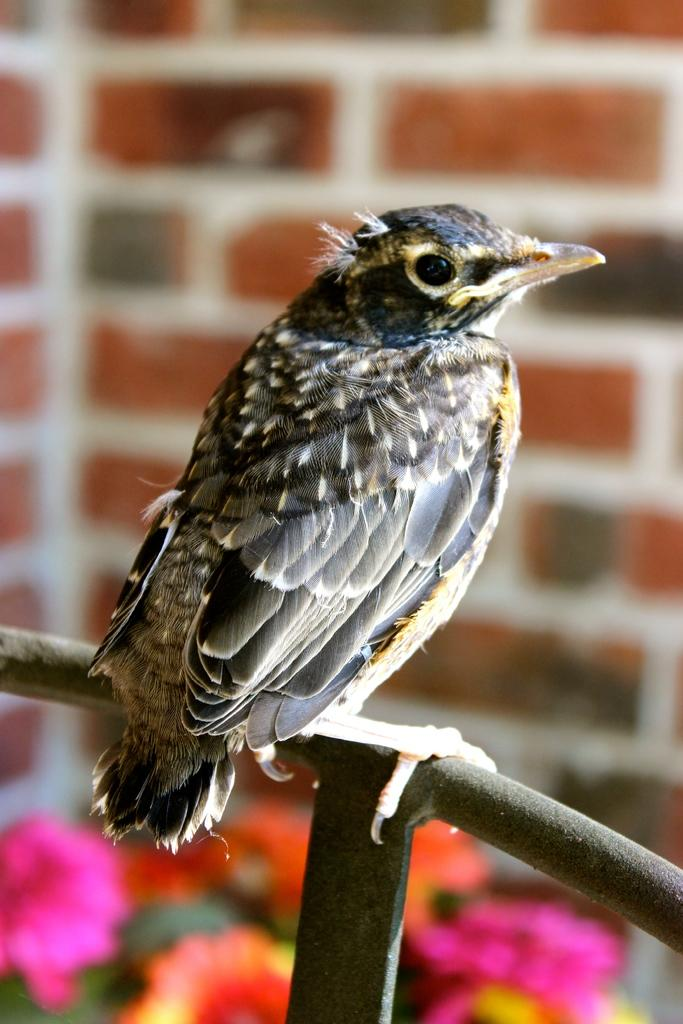What type of animal is in the image? There is a bird in the image. Where is the bird located? The bird is on a rod. Can you describe the background of the image? The background of the image is blurred. What decision does the butter make in the image? There is no butter present in the image, so it cannot make any decisions. 